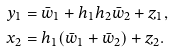Convert formula to latex. <formula><loc_0><loc_0><loc_500><loc_500>y _ { 1 } & = \bar { w } _ { 1 } + h _ { 1 } h _ { 2 } \bar { w } _ { 2 } + z _ { 1 } , \\ x _ { 2 } & = h _ { 1 } ( \bar { w } _ { 1 } + \bar { w } _ { 2 } ) + z _ { 2 } .</formula> 